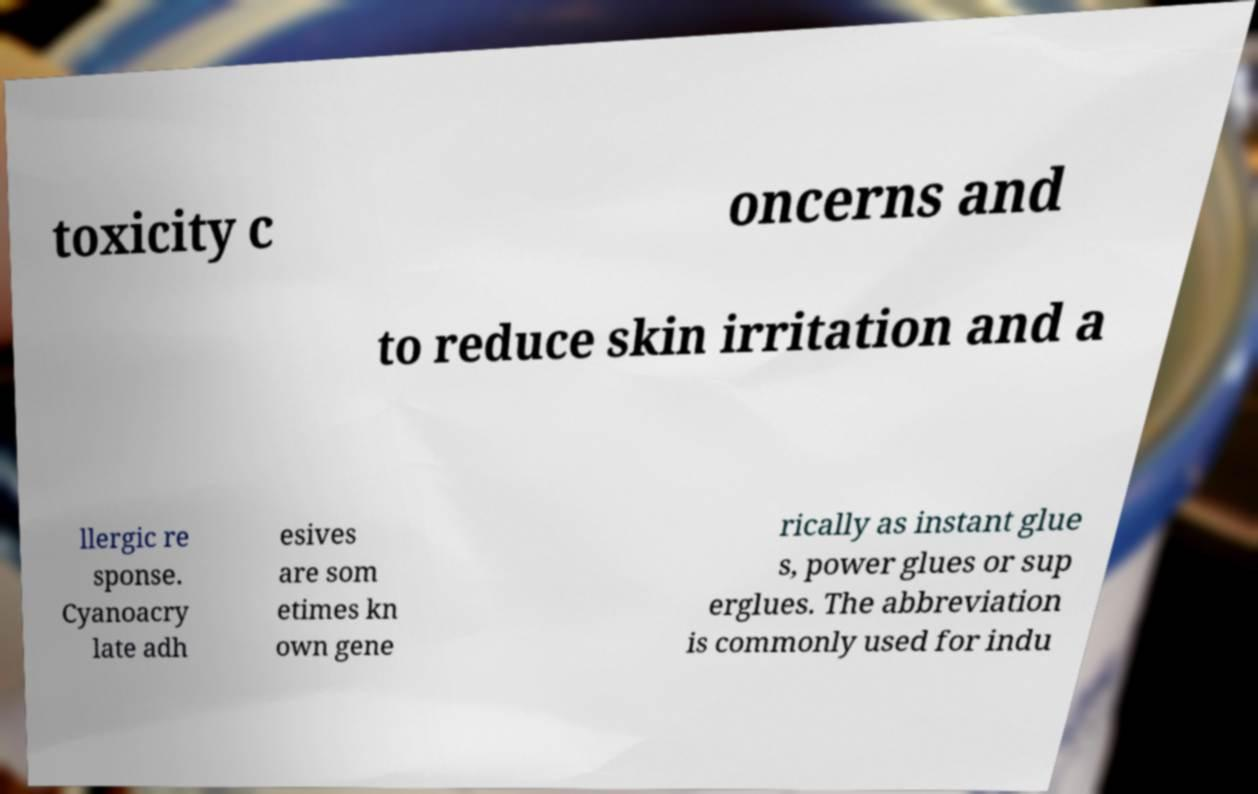What messages or text are displayed in this image? I need them in a readable, typed format. toxicity c oncerns and to reduce skin irritation and a llergic re sponse. Cyanoacry late adh esives are som etimes kn own gene rically as instant glue s, power glues or sup erglues. The abbreviation is commonly used for indu 